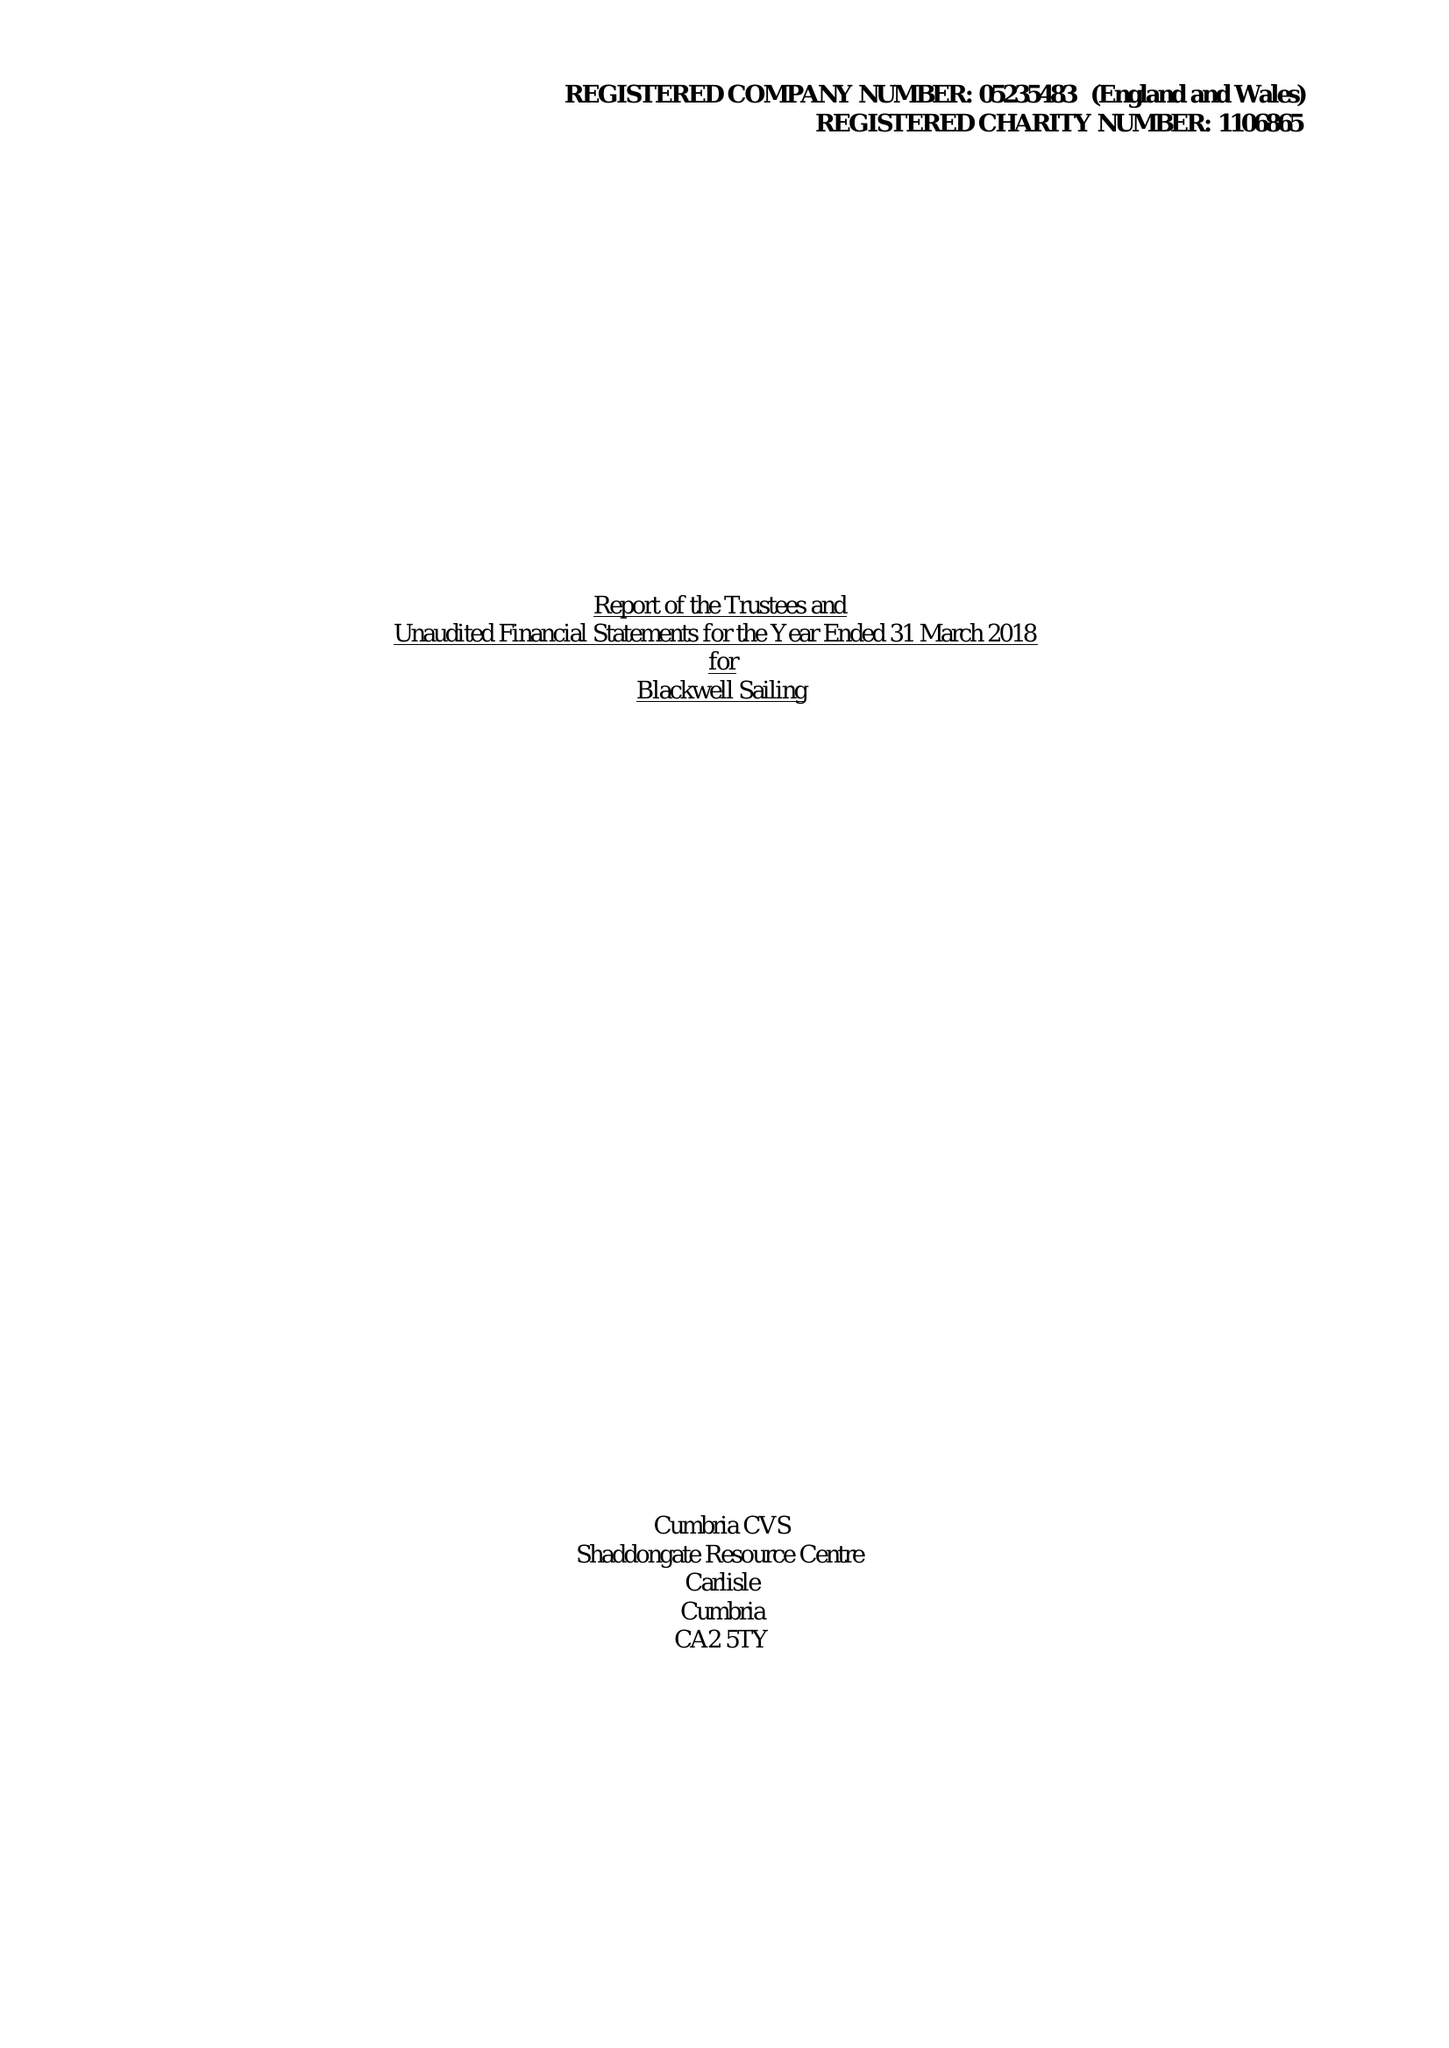What is the value for the spending_annually_in_british_pounds?
Answer the question using a single word or phrase. 73526.00 